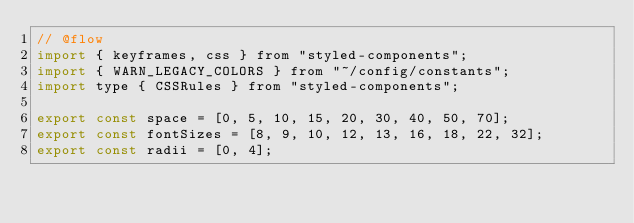Convert code to text. <code><loc_0><loc_0><loc_500><loc_500><_JavaScript_>// @flow
import { keyframes, css } from "styled-components";
import { WARN_LEGACY_COLORS } from "~/config/constants";
import type { CSSRules } from "styled-components";

export const space = [0, 5, 10, 15, 20, 30, 40, 50, 70];
export const fontSizes = [8, 9, 10, 12, 13, 16, 18, 22, 32];
export const radii = [0, 4];</code> 